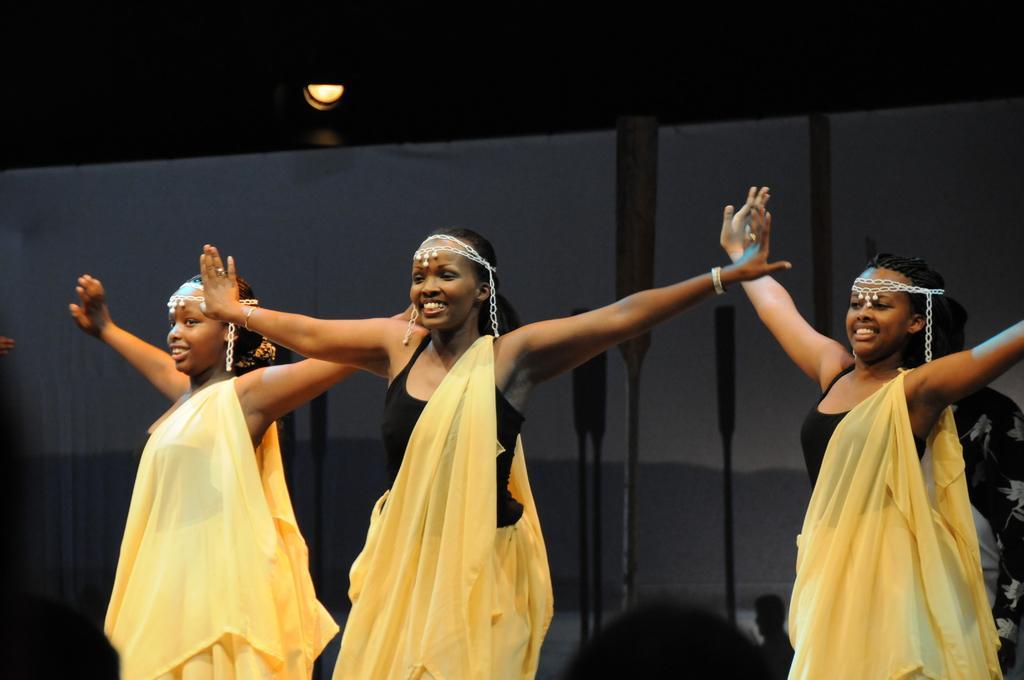Could you give a brief overview of what you see in this image? In this image, we can see girls dancing. 